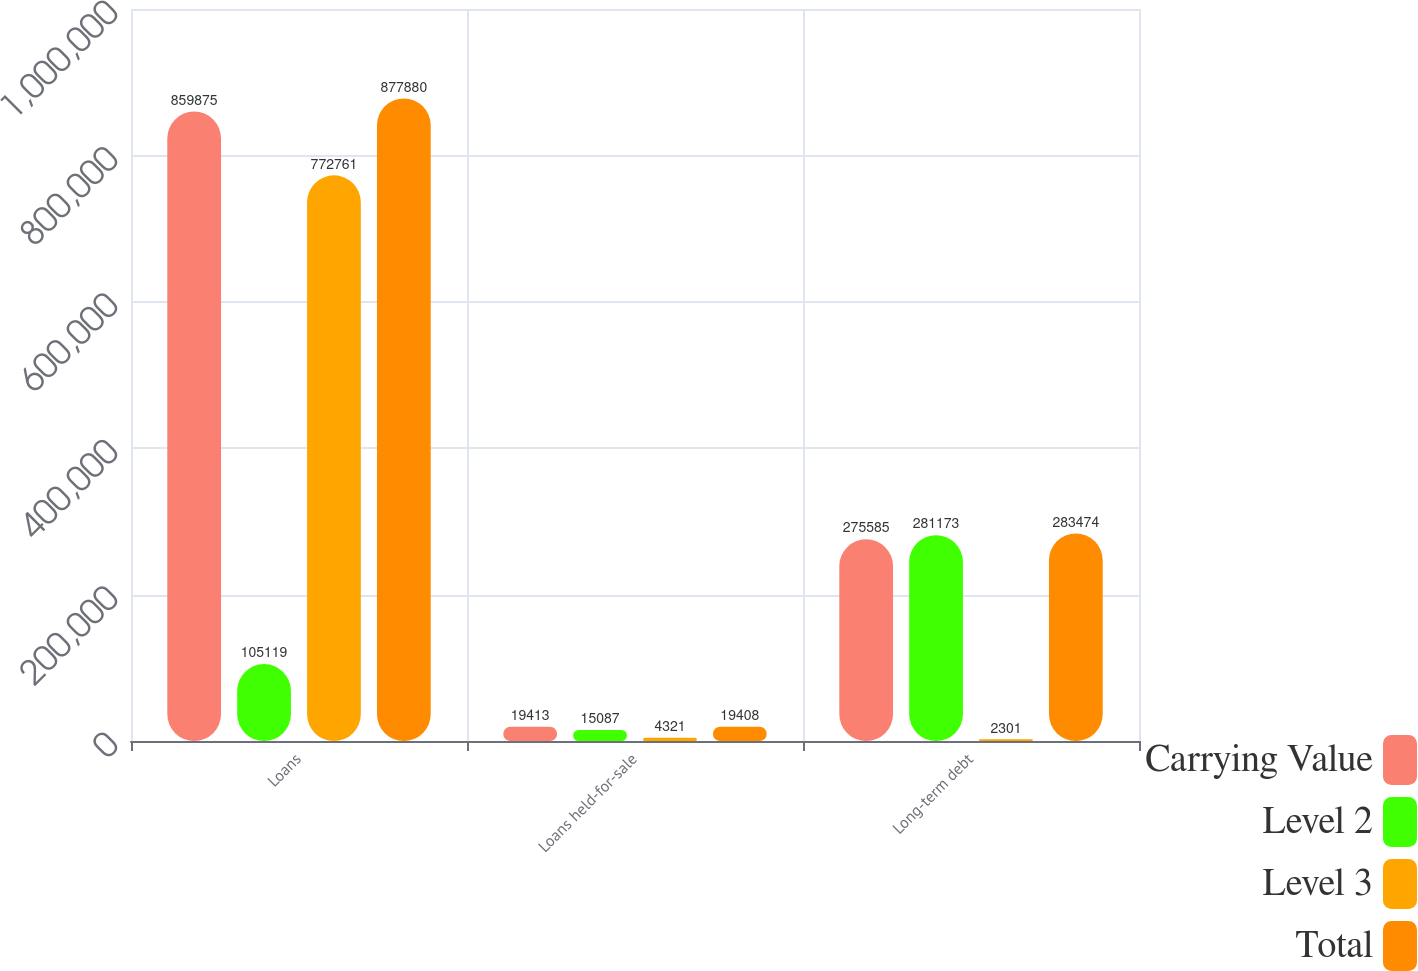Convert chart. <chart><loc_0><loc_0><loc_500><loc_500><stacked_bar_chart><ecel><fcel>Loans<fcel>Loans held-for-sale<fcel>Long-term debt<nl><fcel>Carrying Value<fcel>859875<fcel>19413<fcel>275585<nl><fcel>Level 2<fcel>105119<fcel>15087<fcel>281173<nl><fcel>Level 3<fcel>772761<fcel>4321<fcel>2301<nl><fcel>Total<fcel>877880<fcel>19408<fcel>283474<nl></chart> 